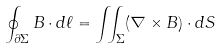Convert formula to latex. <formula><loc_0><loc_0><loc_500><loc_500>\oint _ { \partial \Sigma } B \cdot d { \ell } = \iint _ { \Sigma } ( \nabla \times B ) \cdot d S</formula> 